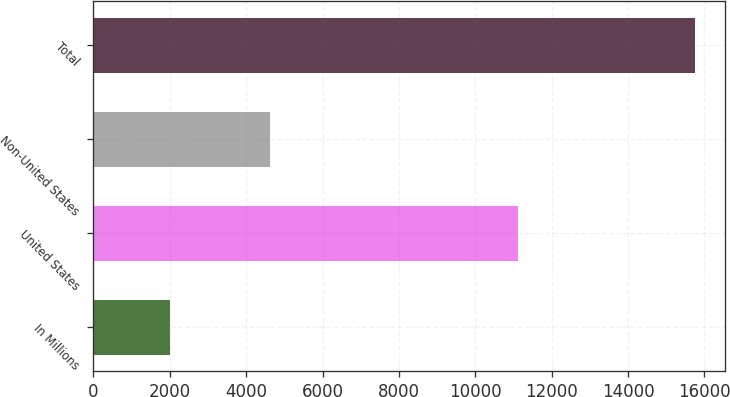Convert chart. <chart><loc_0><loc_0><loc_500><loc_500><bar_chart><fcel>In Millions<fcel>United States<fcel>Non-United States<fcel>Total<nl><fcel>2018<fcel>11115.6<fcel>4624.8<fcel>15740.4<nl></chart> 